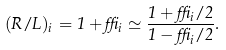Convert formula to latex. <formula><loc_0><loc_0><loc_500><loc_500>( R / L ) _ { i } = 1 + \delta _ { i } \simeq \frac { 1 + \delta _ { i } / 2 } { 1 - \delta _ { i } / 2 } .</formula> 